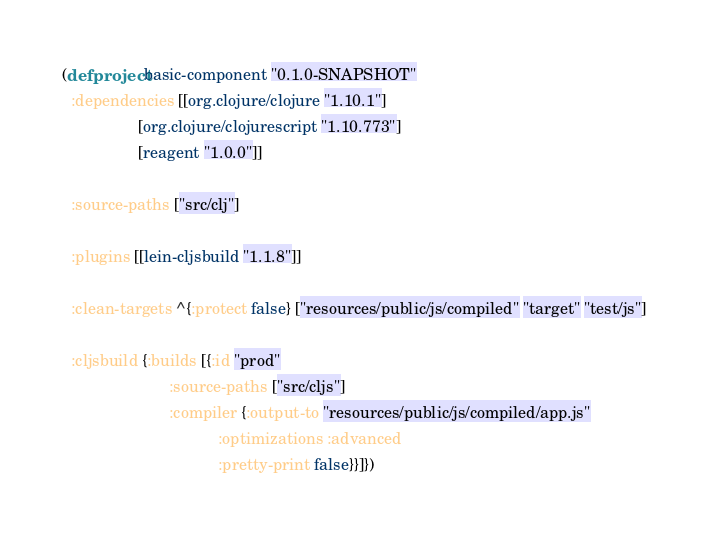<code> <loc_0><loc_0><loc_500><loc_500><_Clojure_>(defproject basic-component "0.1.0-SNAPSHOT"
  :dependencies [[org.clojure/clojure "1.10.1"]
                 [org.clojure/clojurescript "1.10.773"]
                 [reagent "1.0.0"]]

  :source-paths ["src/clj"]

  :plugins [[lein-cljsbuild "1.1.8"]]

  :clean-targets ^{:protect false} ["resources/public/js/compiled" "target" "test/js"]

  :cljsbuild {:builds [{:id "prod"
                        :source-paths ["src/cljs"]
                        :compiler {:output-to "resources/public/js/compiled/app.js"
                                   :optimizations :advanced
                                   :pretty-print false}}]})
</code> 